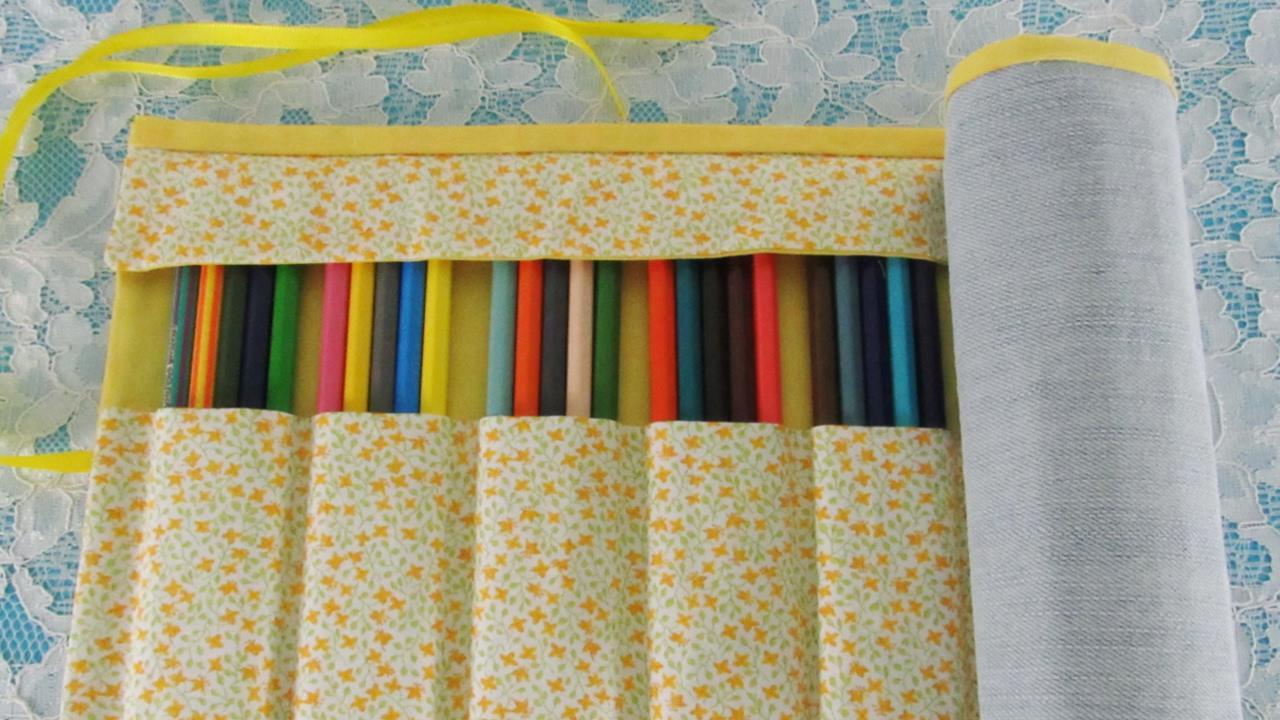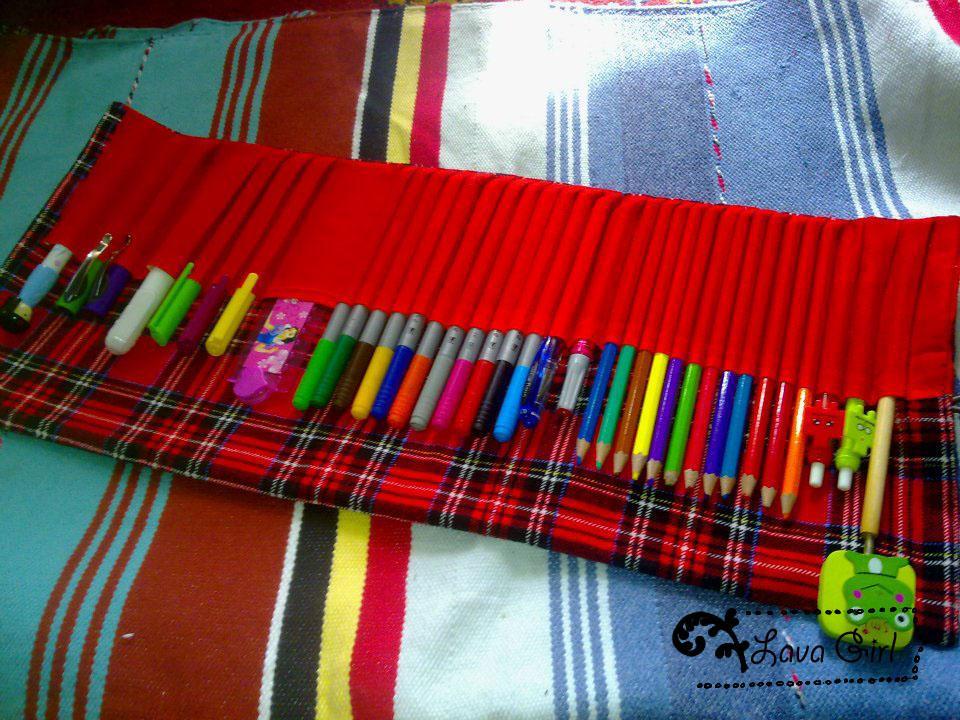The first image is the image on the left, the second image is the image on the right. Evaluate the accuracy of this statement regarding the images: "One image shows an unrolled pencil case with a solid red and tartan plaid interior, and the other shows a case with a small printed pattern on its interior.". Is it true? Answer yes or no. Yes. The first image is the image on the left, the second image is the image on the right. Assess this claim about the two images: "In one image, a red plaid pencil case is unrolled, revealing a long red pocket that contains a collection of pencils, markers, pens, and a green frog eraser.". Correct or not? Answer yes or no. Yes. 